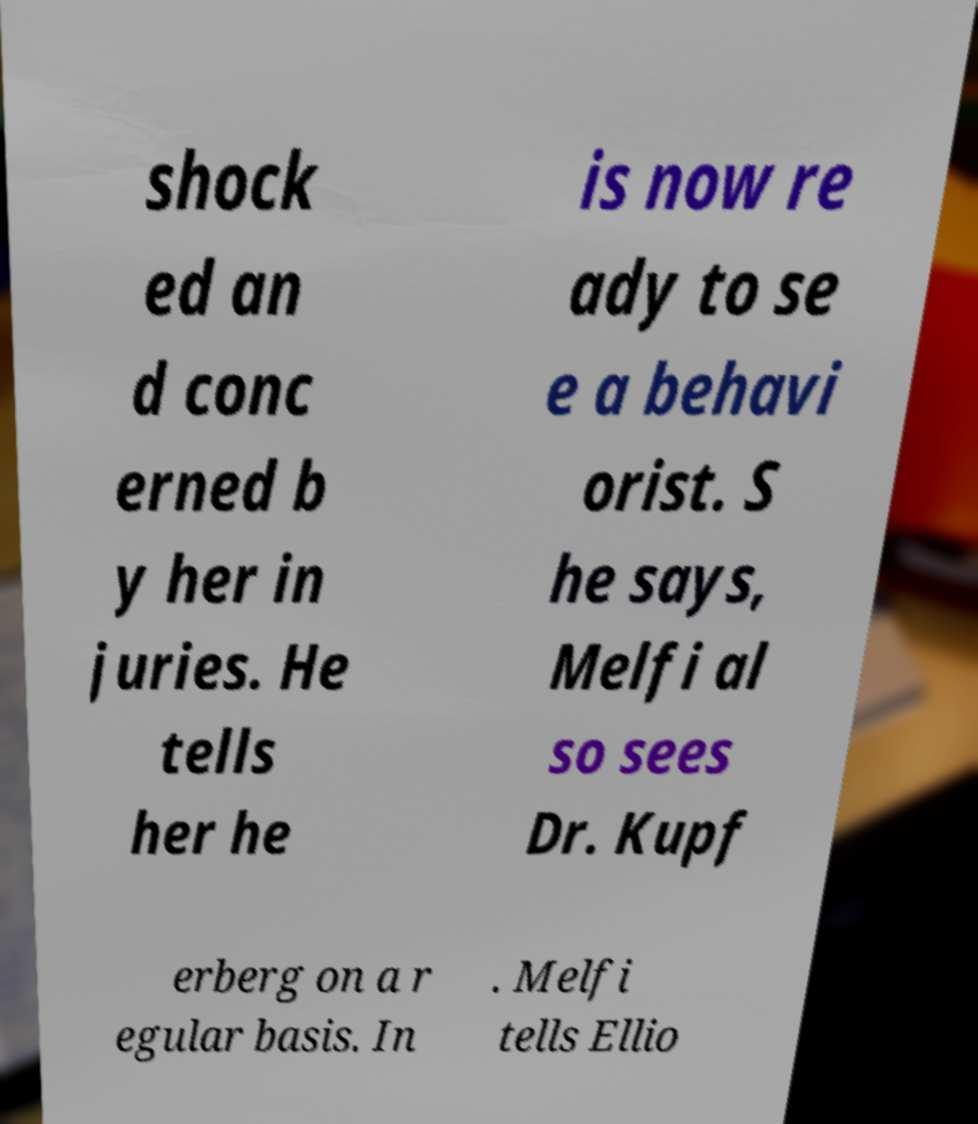Can you read and provide the text displayed in the image?This photo seems to have some interesting text. Can you extract and type it out for me? shock ed an d conc erned b y her in juries. He tells her he is now re ady to se e a behavi orist. S he says, Melfi al so sees Dr. Kupf erberg on a r egular basis. In . Melfi tells Ellio 